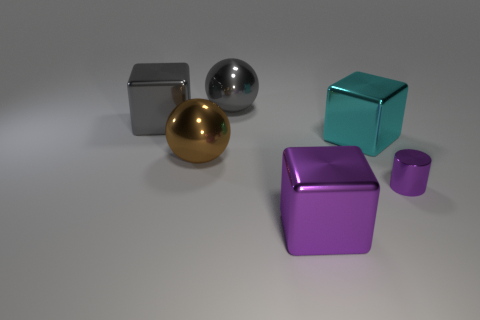Are there any other things that have the same size as the purple shiny cylinder?
Your answer should be very brief. No. What material is the purple thing that is the same shape as the large cyan object?
Offer a terse response. Metal. What number of matte things are brown objects or small blue objects?
Ensure brevity in your answer.  0. There is a big purple thing that is the same material as the brown object; what is its shape?
Provide a short and direct response. Cube. What number of big gray objects are the same shape as the big purple thing?
Offer a terse response. 1. Does the big shiny object to the right of the big purple shiny thing have the same shape as the large thing that is on the left side of the brown shiny object?
Provide a short and direct response. Yes. What number of things are big purple rubber things or spheres behind the large gray block?
Your answer should be very brief. 1. There is a object that is the same color as the shiny cylinder; what is its shape?
Offer a very short reply. Cube. How many metal spheres are the same size as the cyan block?
Your answer should be very brief. 2. What number of yellow things are either small cylinders or large metal balls?
Your response must be concise. 0. 